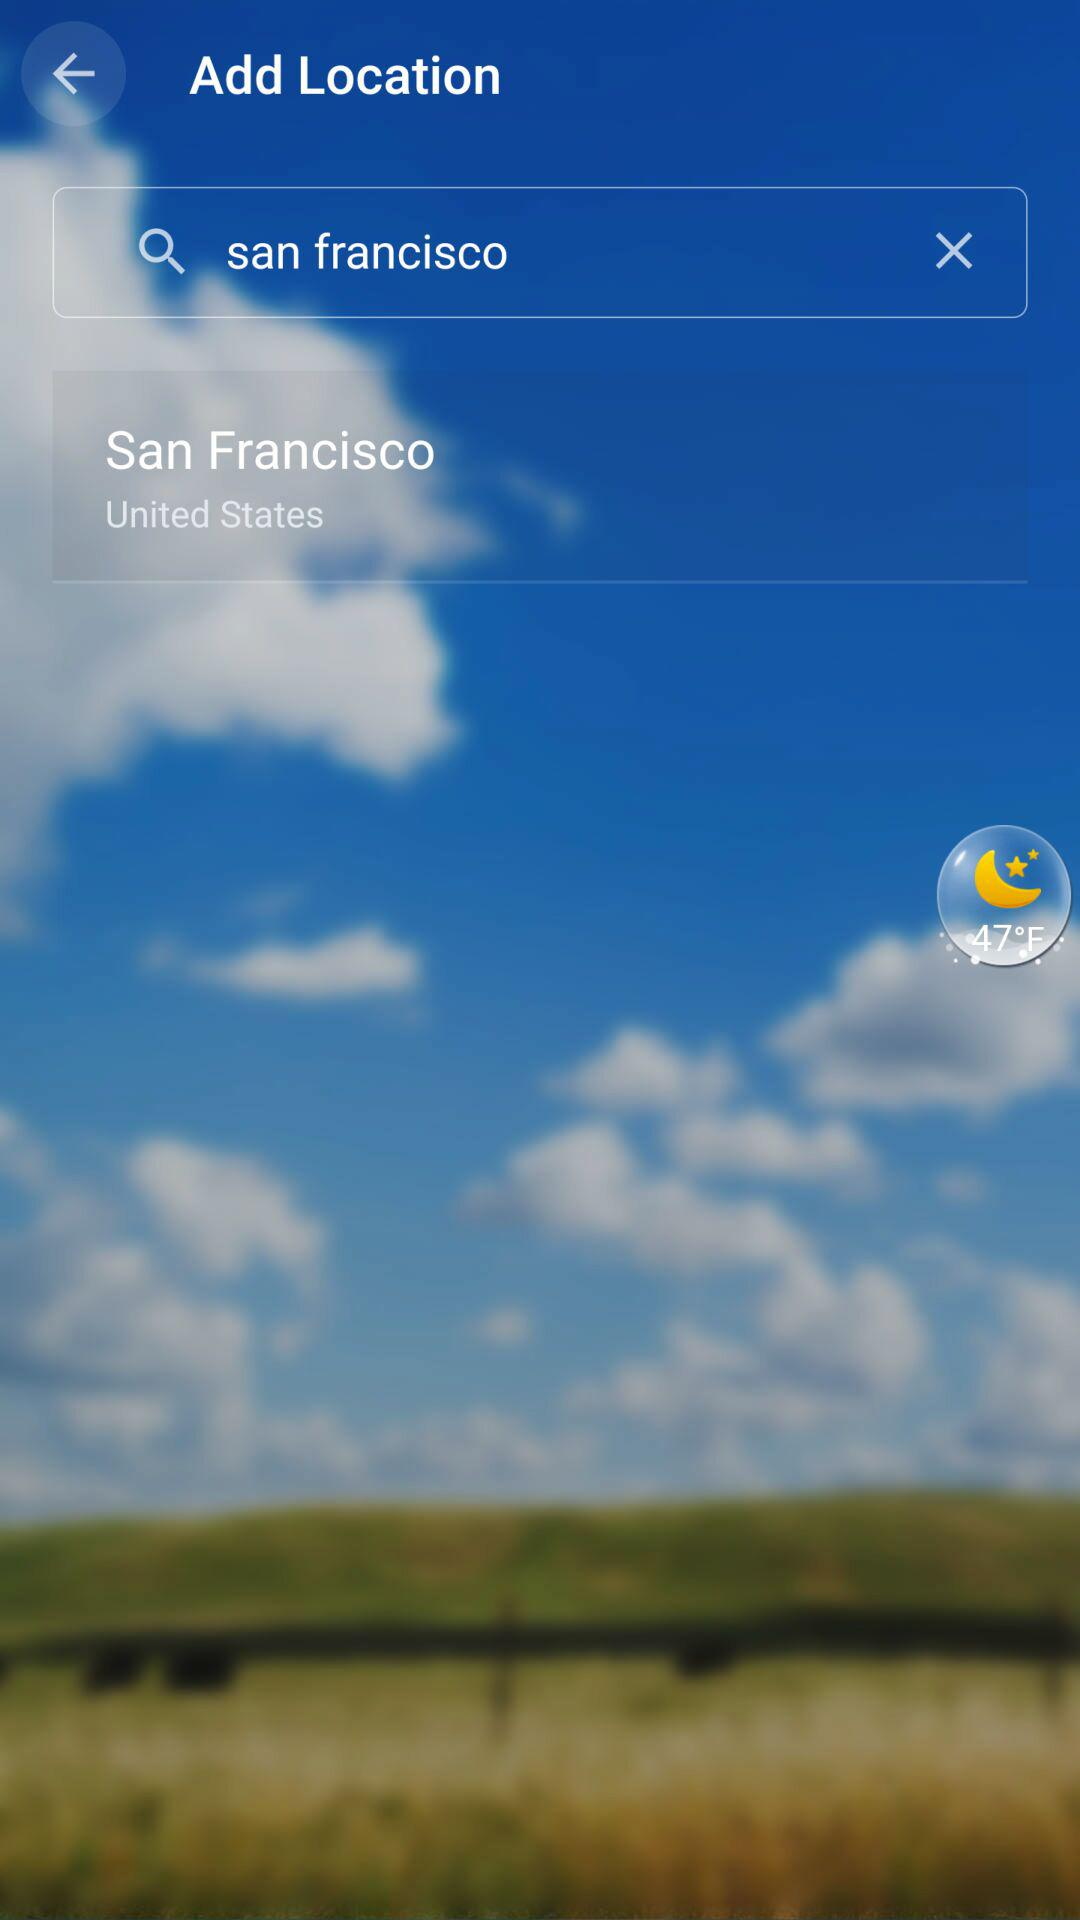What is the temperature? The temperature is 47°F. 